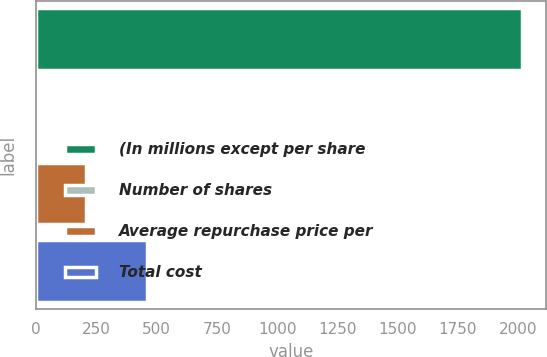<chart> <loc_0><loc_0><loc_500><loc_500><bar_chart><fcel>(In millions except per share<fcel>Number of shares<fcel>Average repurchase price per<fcel>Total cost<nl><fcel>2016<fcel>5.7<fcel>206.73<fcel>461.3<nl></chart> 